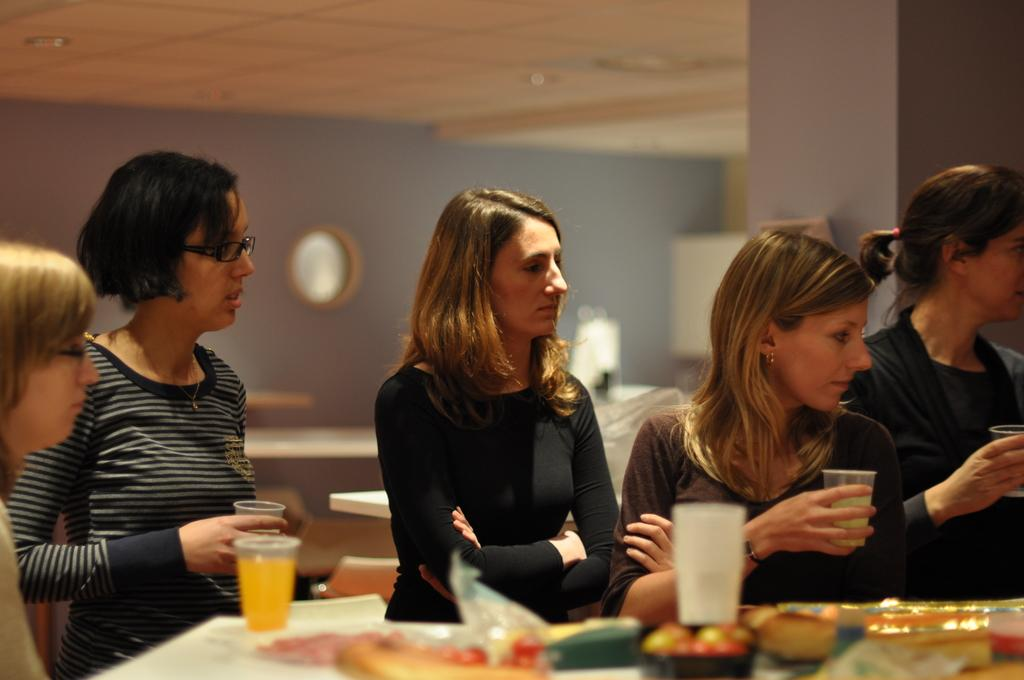How many women are present in the image? There are five women in the image. What are the women doing in the image? The women are sitting in front of a table. What can be seen on the table in the image? There are glasses and food items on the table. What is visible in the background of the image? There is a wall in the background of the image. Where is the market located in the image? There is no market present in the image. What type of collar can be seen on the man in the image? There is no man present in the image, and therefore no collar can be seen. 